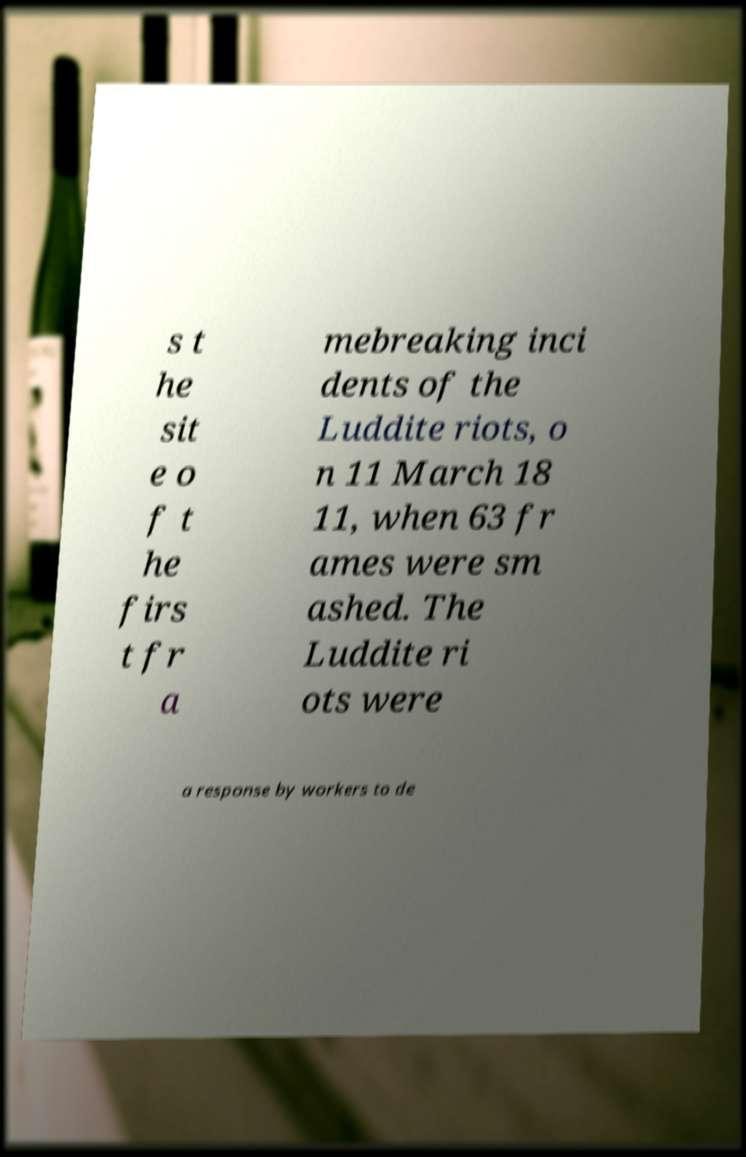Could you assist in decoding the text presented in this image and type it out clearly? s t he sit e o f t he firs t fr a mebreaking inci dents of the Luddite riots, o n 11 March 18 11, when 63 fr ames were sm ashed. The Luddite ri ots were a response by workers to de 